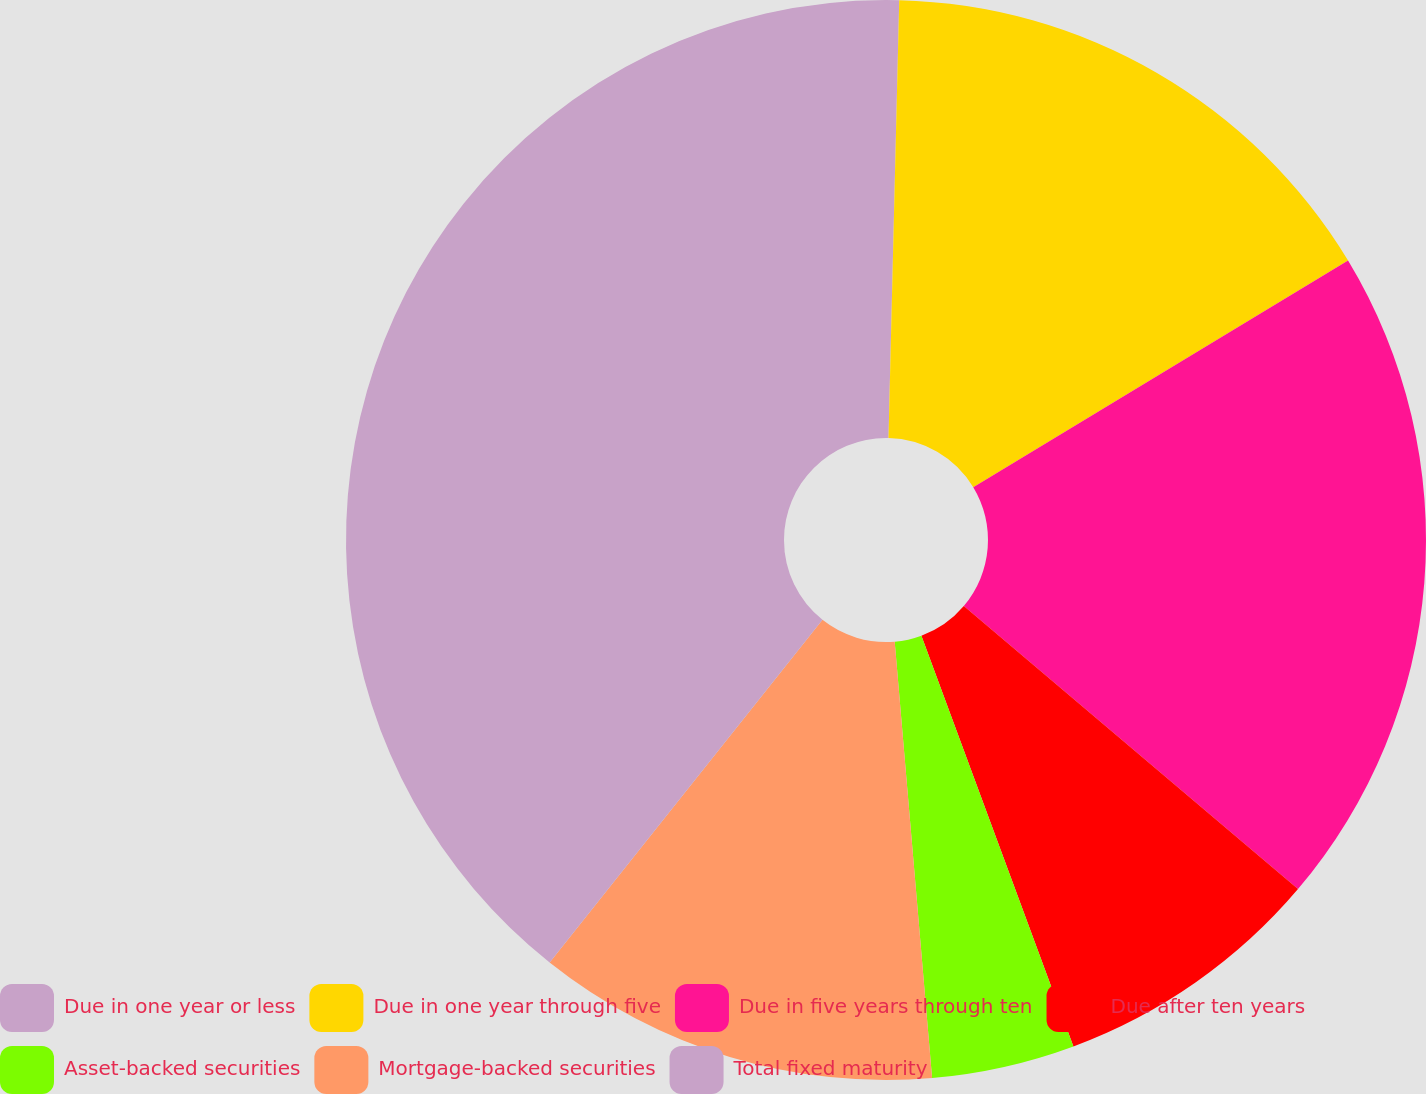<chart> <loc_0><loc_0><loc_500><loc_500><pie_chart><fcel>Due in one year or less<fcel>Due in one year through five<fcel>Due in five years through ten<fcel>Due after ten years<fcel>Asset-backed securities<fcel>Mortgage-backed securities<fcel>Total fixed maturity<nl><fcel>0.39%<fcel>15.95%<fcel>19.84%<fcel>8.17%<fcel>4.28%<fcel>12.06%<fcel>39.29%<nl></chart> 